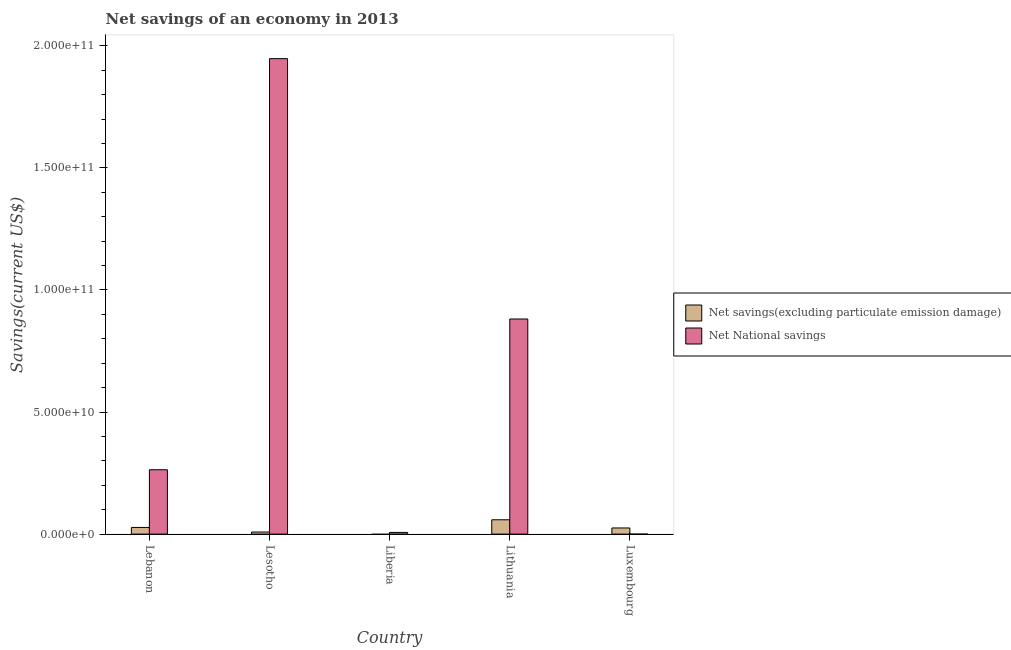Are the number of bars per tick equal to the number of legend labels?
Keep it short and to the point. No. How many bars are there on the 2nd tick from the left?
Your answer should be very brief. 2. What is the label of the 2nd group of bars from the left?
Provide a short and direct response. Lesotho. In how many cases, is the number of bars for a given country not equal to the number of legend labels?
Give a very brief answer. 2. What is the net national savings in Lesotho?
Your response must be concise. 1.95e+11. Across all countries, what is the maximum net national savings?
Your answer should be very brief. 1.95e+11. In which country was the net national savings maximum?
Your answer should be very brief. Lesotho. What is the total net savings(excluding particulate emission damage) in the graph?
Your answer should be compact. 1.20e+1. What is the difference between the net savings(excluding particulate emission damage) in Lesotho and that in Luxembourg?
Offer a very short reply. -1.68e+09. What is the difference between the net savings(excluding particulate emission damage) in Lesotho and the net national savings in Lebanon?
Your answer should be very brief. -2.55e+1. What is the average net savings(excluding particulate emission damage) per country?
Offer a very short reply. 2.39e+09. What is the difference between the net savings(excluding particulate emission damage) and net national savings in Lebanon?
Your answer should be very brief. -2.36e+1. What is the ratio of the net savings(excluding particulate emission damage) in Lebanon to that in Lithuania?
Offer a very short reply. 0.46. What is the difference between the highest and the second highest net savings(excluding particulate emission damage)?
Your response must be concise. 3.14e+09. What is the difference between the highest and the lowest net national savings?
Offer a very short reply. 1.95e+11. Is the sum of the net national savings in Liberia and Lithuania greater than the maximum net savings(excluding particulate emission damage) across all countries?
Keep it short and to the point. Yes. Are all the bars in the graph horizontal?
Keep it short and to the point. No. How many countries are there in the graph?
Provide a succinct answer. 5. Does the graph contain any zero values?
Provide a succinct answer. Yes. Does the graph contain grids?
Keep it short and to the point. No. How are the legend labels stacked?
Give a very brief answer. Vertical. What is the title of the graph?
Provide a succinct answer. Net savings of an economy in 2013. What is the label or title of the Y-axis?
Your answer should be compact. Savings(current US$). What is the Savings(current US$) in Net savings(excluding particulate emission damage) in Lebanon?
Provide a short and direct response. 2.73e+09. What is the Savings(current US$) in Net National savings in Lebanon?
Your answer should be compact. 2.64e+1. What is the Savings(current US$) in Net savings(excluding particulate emission damage) in Lesotho?
Offer a terse response. 8.42e+08. What is the Savings(current US$) of Net National savings in Lesotho?
Your answer should be compact. 1.95e+11. What is the Savings(current US$) in Net National savings in Liberia?
Give a very brief answer. 6.92e+08. What is the Savings(current US$) in Net savings(excluding particulate emission damage) in Lithuania?
Your answer should be compact. 5.87e+09. What is the Savings(current US$) of Net National savings in Lithuania?
Provide a short and direct response. 8.81e+1. What is the Savings(current US$) in Net savings(excluding particulate emission damage) in Luxembourg?
Provide a succinct answer. 2.52e+09. Across all countries, what is the maximum Savings(current US$) in Net savings(excluding particulate emission damage)?
Make the answer very short. 5.87e+09. Across all countries, what is the maximum Savings(current US$) in Net National savings?
Ensure brevity in your answer.  1.95e+11. Across all countries, what is the minimum Savings(current US$) of Net savings(excluding particulate emission damage)?
Provide a succinct answer. 0. Across all countries, what is the minimum Savings(current US$) in Net National savings?
Keep it short and to the point. 0. What is the total Savings(current US$) in Net savings(excluding particulate emission damage) in the graph?
Ensure brevity in your answer.  1.20e+1. What is the total Savings(current US$) in Net National savings in the graph?
Give a very brief answer. 3.10e+11. What is the difference between the Savings(current US$) in Net savings(excluding particulate emission damage) in Lebanon and that in Lesotho?
Keep it short and to the point. 1.88e+09. What is the difference between the Savings(current US$) in Net National savings in Lebanon and that in Lesotho?
Keep it short and to the point. -1.68e+11. What is the difference between the Savings(current US$) in Net National savings in Lebanon and that in Liberia?
Keep it short and to the point. 2.57e+1. What is the difference between the Savings(current US$) of Net savings(excluding particulate emission damage) in Lebanon and that in Lithuania?
Ensure brevity in your answer.  -3.14e+09. What is the difference between the Savings(current US$) of Net National savings in Lebanon and that in Lithuania?
Offer a very short reply. -6.17e+1. What is the difference between the Savings(current US$) in Net savings(excluding particulate emission damage) in Lebanon and that in Luxembourg?
Your response must be concise. 2.08e+08. What is the difference between the Savings(current US$) of Net National savings in Lesotho and that in Liberia?
Provide a short and direct response. 1.94e+11. What is the difference between the Savings(current US$) of Net savings(excluding particulate emission damage) in Lesotho and that in Lithuania?
Keep it short and to the point. -5.03e+09. What is the difference between the Savings(current US$) of Net National savings in Lesotho and that in Lithuania?
Offer a very short reply. 1.07e+11. What is the difference between the Savings(current US$) in Net savings(excluding particulate emission damage) in Lesotho and that in Luxembourg?
Make the answer very short. -1.68e+09. What is the difference between the Savings(current US$) of Net National savings in Liberia and that in Lithuania?
Make the answer very short. -8.74e+1. What is the difference between the Savings(current US$) in Net savings(excluding particulate emission damage) in Lithuania and that in Luxembourg?
Provide a short and direct response. 3.35e+09. What is the difference between the Savings(current US$) of Net savings(excluding particulate emission damage) in Lebanon and the Savings(current US$) of Net National savings in Lesotho?
Offer a terse response. -1.92e+11. What is the difference between the Savings(current US$) in Net savings(excluding particulate emission damage) in Lebanon and the Savings(current US$) in Net National savings in Liberia?
Your response must be concise. 2.03e+09. What is the difference between the Savings(current US$) in Net savings(excluding particulate emission damage) in Lebanon and the Savings(current US$) in Net National savings in Lithuania?
Offer a very short reply. -8.54e+1. What is the difference between the Savings(current US$) of Net savings(excluding particulate emission damage) in Lesotho and the Savings(current US$) of Net National savings in Liberia?
Offer a very short reply. 1.50e+08. What is the difference between the Savings(current US$) of Net savings(excluding particulate emission damage) in Lesotho and the Savings(current US$) of Net National savings in Lithuania?
Offer a very short reply. -8.73e+1. What is the average Savings(current US$) in Net savings(excluding particulate emission damage) per country?
Keep it short and to the point. 2.39e+09. What is the average Savings(current US$) of Net National savings per country?
Your answer should be very brief. 6.20e+1. What is the difference between the Savings(current US$) in Net savings(excluding particulate emission damage) and Savings(current US$) in Net National savings in Lebanon?
Your answer should be very brief. -2.36e+1. What is the difference between the Savings(current US$) of Net savings(excluding particulate emission damage) and Savings(current US$) of Net National savings in Lesotho?
Your answer should be compact. -1.94e+11. What is the difference between the Savings(current US$) of Net savings(excluding particulate emission damage) and Savings(current US$) of Net National savings in Lithuania?
Ensure brevity in your answer.  -8.22e+1. What is the ratio of the Savings(current US$) of Net savings(excluding particulate emission damage) in Lebanon to that in Lesotho?
Ensure brevity in your answer.  3.24. What is the ratio of the Savings(current US$) of Net National savings in Lebanon to that in Lesotho?
Give a very brief answer. 0.14. What is the ratio of the Savings(current US$) in Net National savings in Lebanon to that in Liberia?
Make the answer very short. 38.07. What is the ratio of the Savings(current US$) in Net savings(excluding particulate emission damage) in Lebanon to that in Lithuania?
Provide a short and direct response. 0.46. What is the ratio of the Savings(current US$) in Net National savings in Lebanon to that in Lithuania?
Your answer should be compact. 0.3. What is the ratio of the Savings(current US$) in Net savings(excluding particulate emission damage) in Lebanon to that in Luxembourg?
Keep it short and to the point. 1.08. What is the ratio of the Savings(current US$) in Net National savings in Lesotho to that in Liberia?
Give a very brief answer. 281.24. What is the ratio of the Savings(current US$) of Net savings(excluding particulate emission damage) in Lesotho to that in Lithuania?
Give a very brief answer. 0.14. What is the ratio of the Savings(current US$) in Net National savings in Lesotho to that in Lithuania?
Make the answer very short. 2.21. What is the ratio of the Savings(current US$) of Net savings(excluding particulate emission damage) in Lesotho to that in Luxembourg?
Give a very brief answer. 0.33. What is the ratio of the Savings(current US$) in Net National savings in Liberia to that in Lithuania?
Ensure brevity in your answer.  0.01. What is the ratio of the Savings(current US$) in Net savings(excluding particulate emission damage) in Lithuania to that in Luxembourg?
Ensure brevity in your answer.  2.33. What is the difference between the highest and the second highest Savings(current US$) in Net savings(excluding particulate emission damage)?
Your response must be concise. 3.14e+09. What is the difference between the highest and the second highest Savings(current US$) in Net National savings?
Give a very brief answer. 1.07e+11. What is the difference between the highest and the lowest Savings(current US$) of Net savings(excluding particulate emission damage)?
Offer a terse response. 5.87e+09. What is the difference between the highest and the lowest Savings(current US$) in Net National savings?
Your answer should be compact. 1.95e+11. 